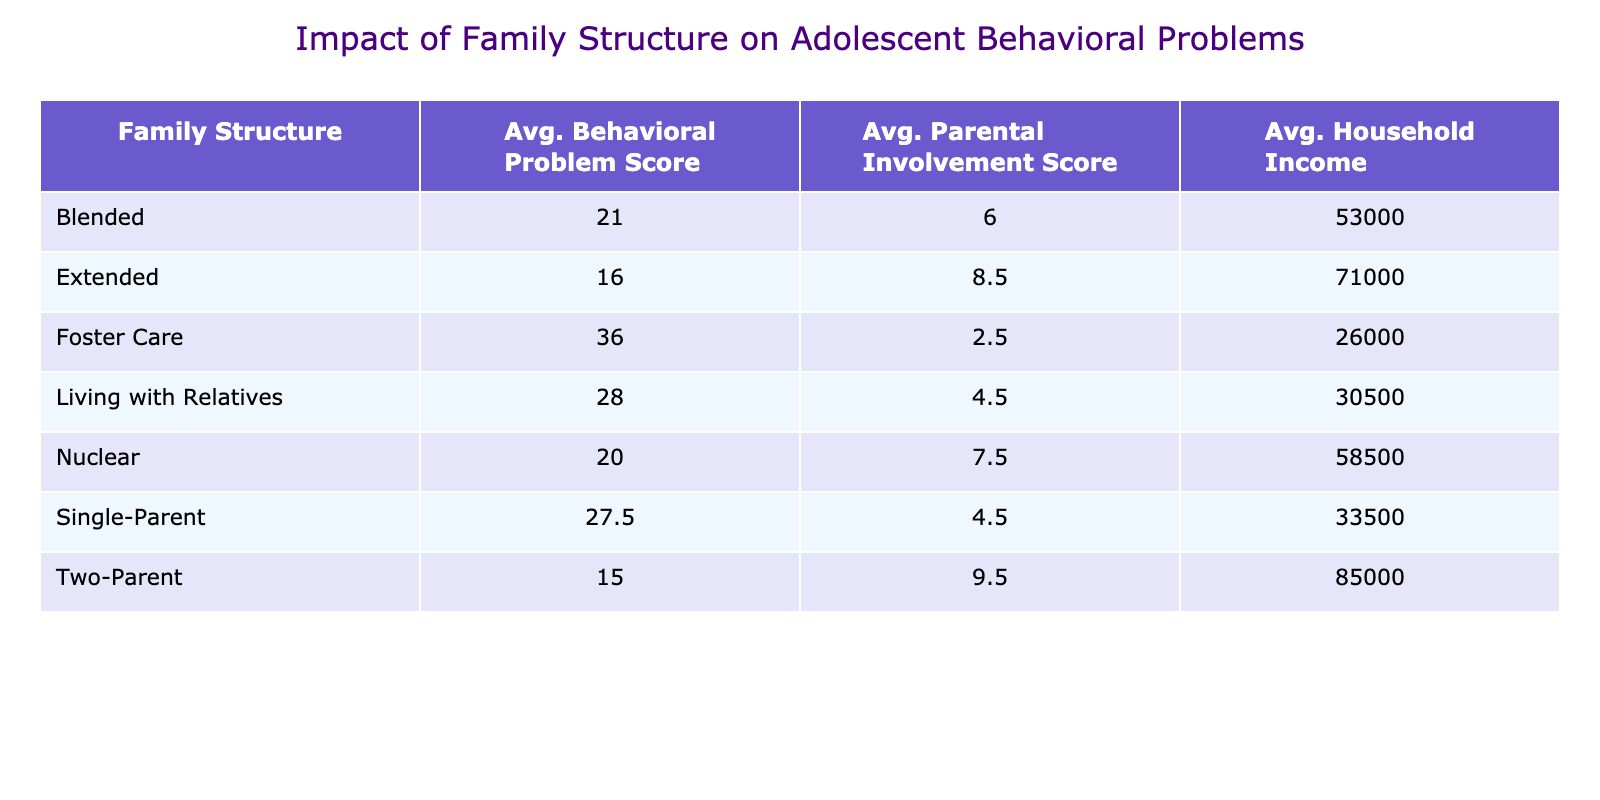What is the average behavioral problem score for adolescents from single-parent families? There are two data points under the 'Single-Parent' category: 30 and 25. To find the average, we sum these scores (30 + 25 = 55) and divide by the number of data points (2). Thus, the average is 55/2 = 27.5.
Answer: 27.5 Which family structure has the highest average parental involvement score? The table lists the average parental involvement scores for each family structure. 'Two-Parent' has the highest average score of 9.5, compared to others, like 'Nuclear' with an average of 7.5. Hence, 'Two-Parent' has the highest score.
Answer: Two-Parent Is the average household income higher for blended families compared to living with relatives? The average household income for 'Blended' families is 52900, while for 'Living with Relatives,' it is 30500. Since 52900 is greater than 30500, the statement is true.
Answer: Yes What is the difference in average behavioral problem scores between foster care and nuclear families? The average for 'Foster Care' is 36 and for 'Nuclear' is 20. To find the difference, we subtract the average of nuclear families from that of foster care: 36 - 20 = 16.
Answer: 16 Which family structure combined has a lower average behavioral problem score, nuclear or blended? The average score for 'Nuclear' families is 20 and for 'Blended' families, it is 21. Since 20 is less than 21, 'Nuclear' families have a lower average score.
Answer: Nuclear What is the total number of average parental involvement scores for all family structures? We add the average parental involvement scores of all family structures: 8 + 7 + 4.5 + 6 + 8.5 + 5 + 9 + 5 = 54. Therefore, the total is 54.
Answer: 54 Is the average behavioral problem score lower for adolescents aged 17 compared to those aged 13? The average score for age 17 is 14 and for age 13 is 27. Since 14 is less than 27, this statement is correct.
Answer: Yes What is the relationship between household income and behavioral problem score in nuclear families? The average household income for 'Nuclear' families is 58500, and their average behavioral problem score is 20. A higher household income correlates with a lower problem score, indicating an inverse relationship.
Answer: Inverse relationship How many family structures have an average behavioral problem score above 25? The family structures with scores above 25 are 'Single-Parent' (27.5) and 'Foster Care' (36). There are two such family structures.
Answer: 2 